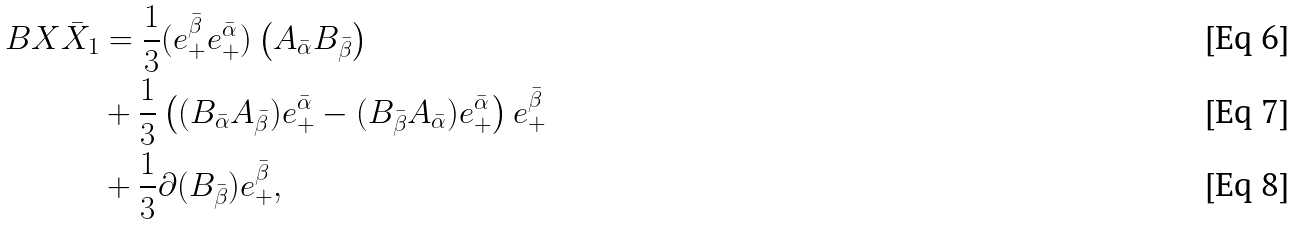<formula> <loc_0><loc_0><loc_500><loc_500>\L B { X } { \bar { X } } _ { 1 } & = \frac { 1 } { 3 } ( e _ { + } ^ { \bar { \beta } } e _ { + } ^ { \bar { \alpha } } ) \left ( A _ { \bar { \alpha } } B _ { \bar { \beta } } \right ) \\ & + \frac { 1 } { 3 } \left ( ( B _ { \bar { \alpha } } A _ { \bar { \beta } } ) e _ { + } ^ { \bar { \alpha } } - ( B _ { \bar { \beta } } A _ { \bar { \alpha } } ) e _ { + } ^ { \bar { \alpha } } \right ) e _ { + } ^ { \bar { \beta } } \\ & + \frac { 1 } { 3 } \partial ( B _ { \bar { \beta } } ) e _ { + } ^ { \bar { \beta } } ,</formula> 